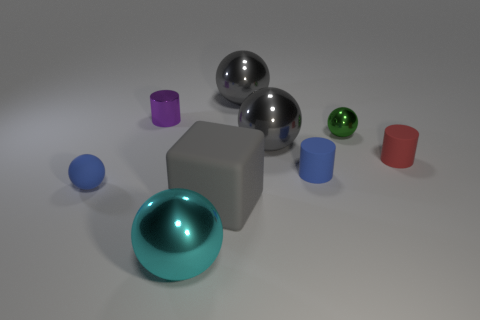How would you categorize the color palette used in this image? The color palette in the image is primarily composed of cool tones such as blues and grays, creating a serene and modern atmosphere. This is complemented by pops of color from the green and red cylinders, adding visual interest and contrast. 